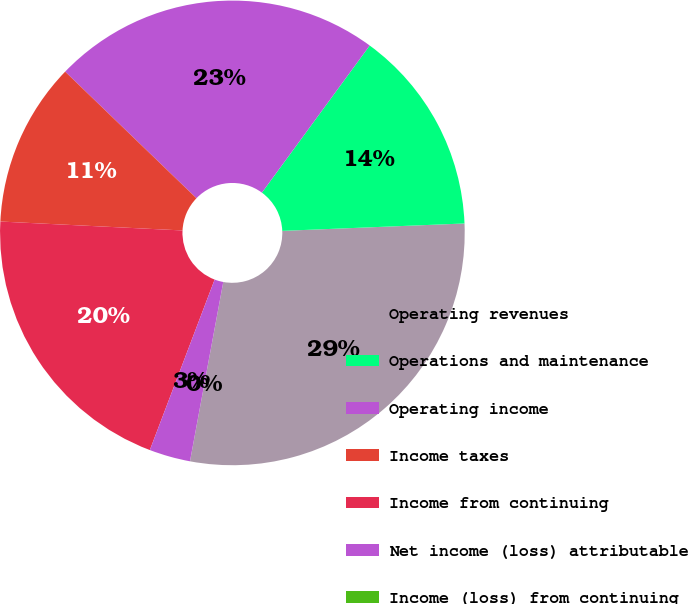Convert chart to OTSL. <chart><loc_0><loc_0><loc_500><loc_500><pie_chart><fcel>Operating revenues<fcel>Operations and maintenance<fcel>Operating income<fcel>Income taxes<fcel>Income from continuing<fcel>Net income (loss) attributable<fcel>Income (loss) from continuing<nl><fcel>28.57%<fcel>14.29%<fcel>22.86%<fcel>11.43%<fcel>20.0%<fcel>2.86%<fcel>0.0%<nl></chart> 